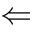Convert formula to latex. <formula><loc_0><loc_0><loc_500><loc_500>\Leftarrow</formula> 